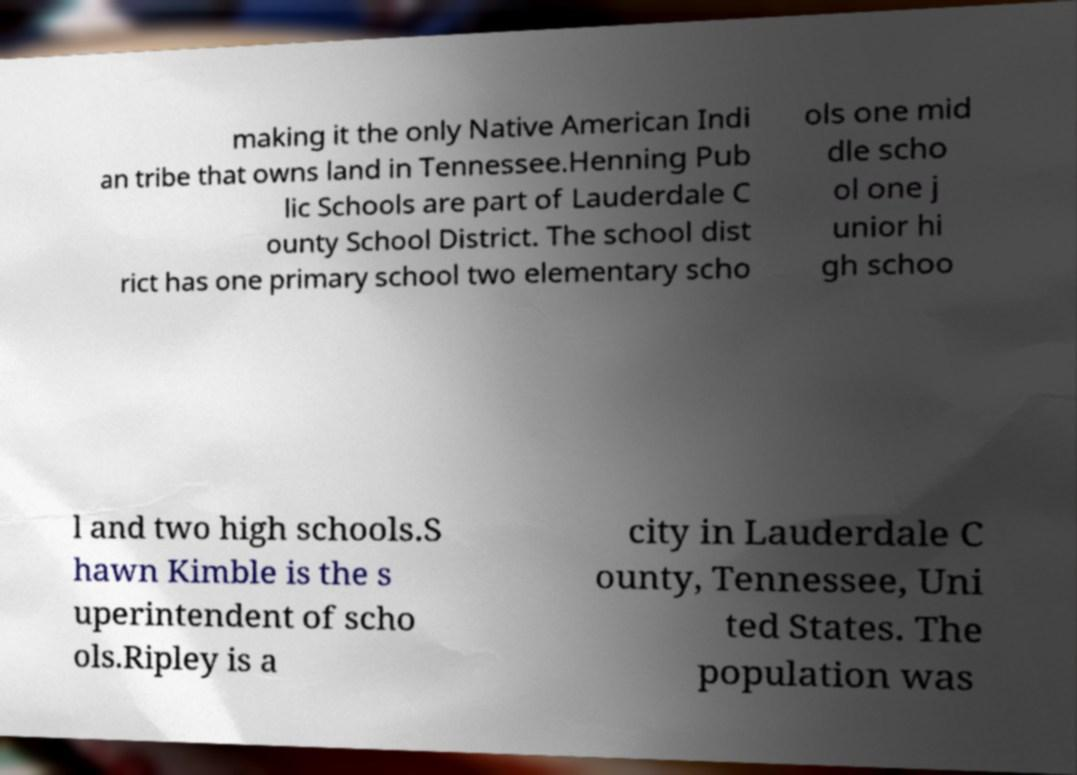For documentation purposes, I need the text within this image transcribed. Could you provide that? making it the only Native American Indi an tribe that owns land in Tennessee.Henning Pub lic Schools are part of Lauderdale C ounty School District. The school dist rict has one primary school two elementary scho ols one mid dle scho ol one j unior hi gh schoo l and two high schools.S hawn Kimble is the s uperintendent of scho ols.Ripley is a city in Lauderdale C ounty, Tennessee, Uni ted States. The population was 